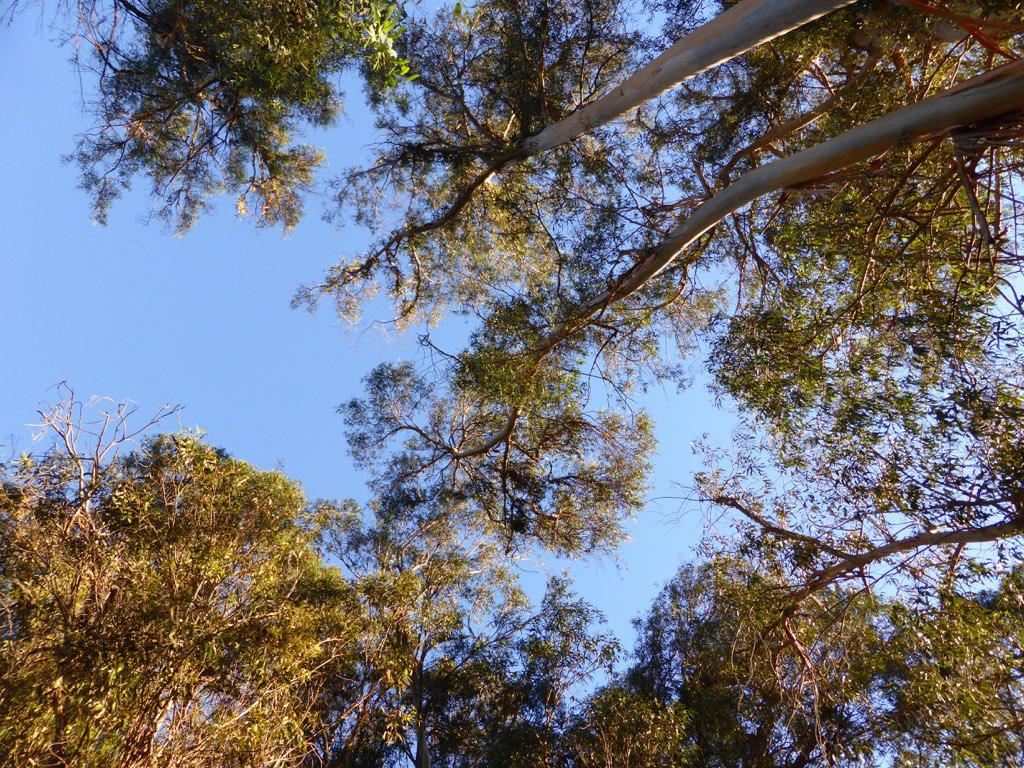What type of vegetation can be seen in the image? There are trees in the image. What is visible at the top of the image? The sky is visible at the top of the image. Can you see a badge on any of the trees in the image? There is no badge present on the trees in the image. Is there a fire visible in the image? There is no fire present in the image. 